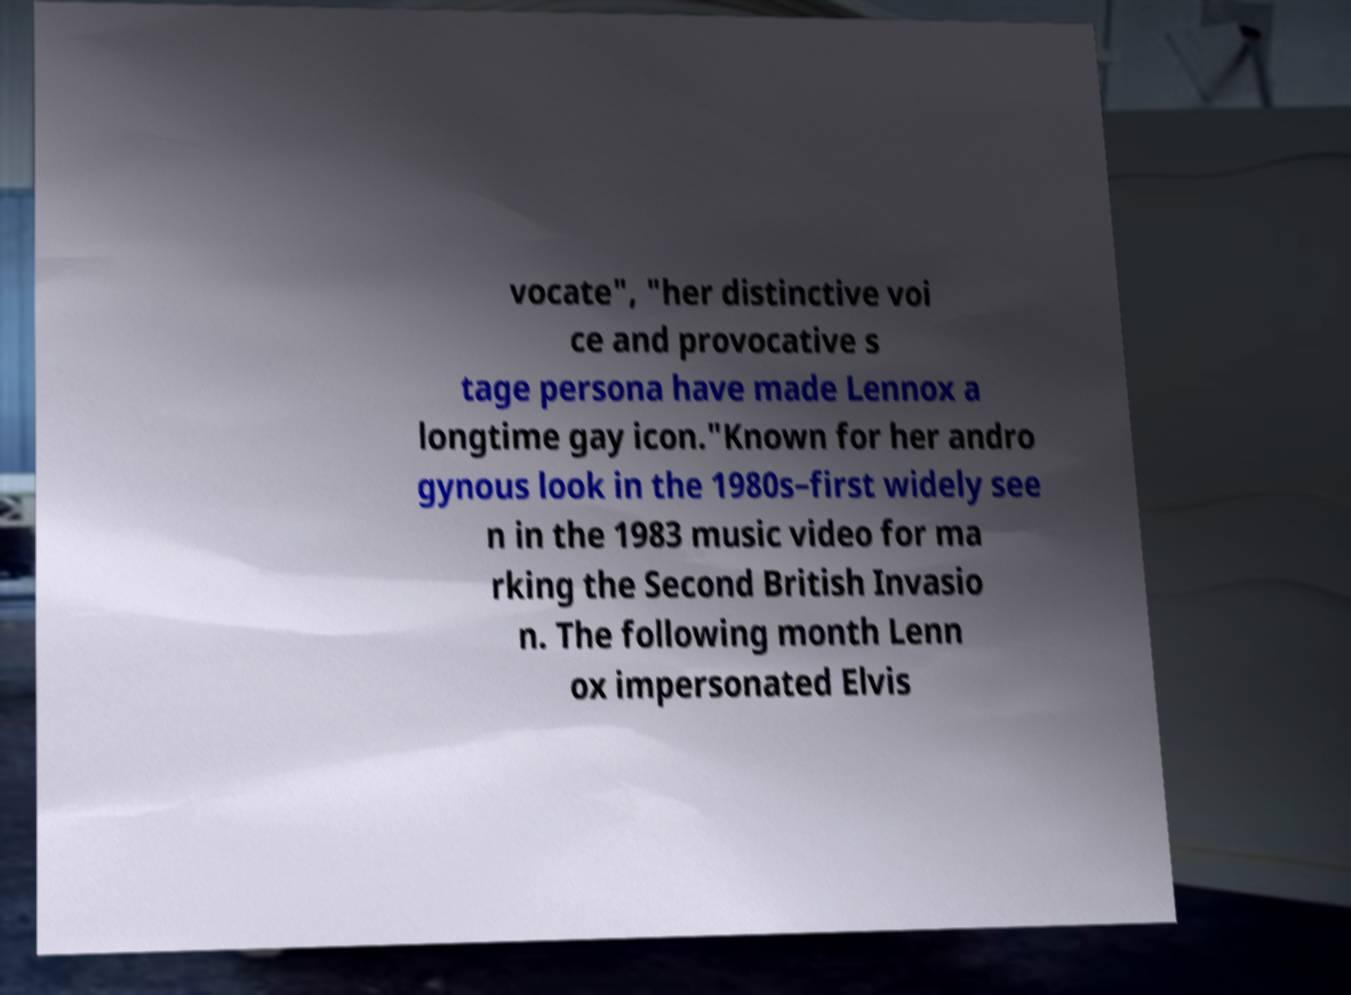Please identify and transcribe the text found in this image. vocate", "her distinctive voi ce and provocative s tage persona have made Lennox a longtime gay icon."Known for her andro gynous look in the 1980s–first widely see n in the 1983 music video for ma rking the Second British Invasio n. The following month Lenn ox impersonated Elvis 